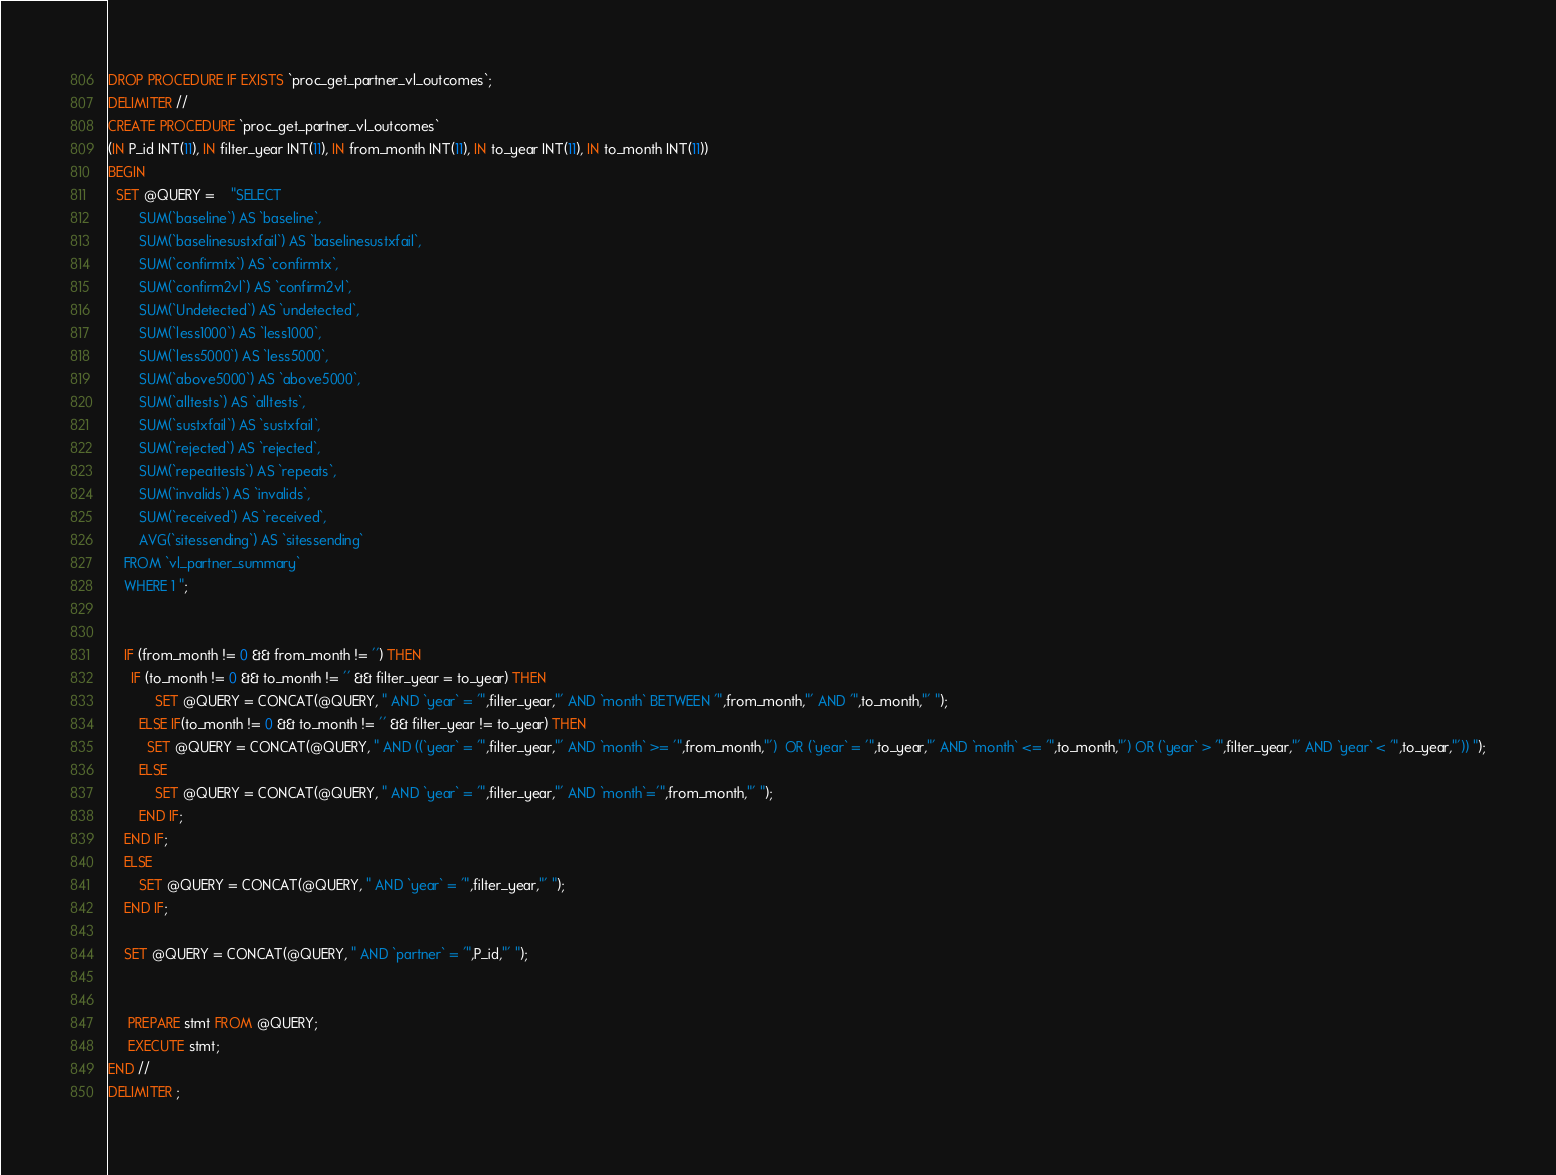<code> <loc_0><loc_0><loc_500><loc_500><_SQL_>DROP PROCEDURE IF EXISTS `proc_get_partner_vl_outcomes`;
DELIMITER //
CREATE PROCEDURE `proc_get_partner_vl_outcomes`
(IN P_id INT(11), IN filter_year INT(11), IN from_month INT(11), IN to_year INT(11), IN to_month INT(11))
BEGIN
  SET @QUERY =    "SELECT
        SUM(`baseline`) AS `baseline`, 
        SUM(`baselinesustxfail`) AS `baselinesustxfail`, 
        SUM(`confirmtx`) AS `confirmtx`,
        SUM(`confirm2vl`) AS `confirm2vl`,
        SUM(`Undetected`) AS `undetected`,
        SUM(`less1000`) AS `less1000`,
        SUM(`less5000`) AS `less5000`,
        SUM(`above5000`) AS `above5000`,
        SUM(`alltests`) AS `alltests`,
        SUM(`sustxfail`) AS `sustxfail`,
        SUM(`rejected`) AS `rejected`, 
        SUM(`repeattests`) AS `repeats`, 
        SUM(`invalids`) AS `invalids`,
        SUM(`received`) AS `received`,
        AVG(`sitessending`) AS `sitessending`
    FROM `vl_partner_summary`
    WHERE 1 ";


    IF (from_month != 0 && from_month != '') THEN
      IF (to_month != 0 && to_month != '' && filter_year = to_year) THEN
            SET @QUERY = CONCAT(@QUERY, " AND `year` = '",filter_year,"' AND `month` BETWEEN '",from_month,"' AND '",to_month,"' ");
        ELSE IF(to_month != 0 && to_month != '' && filter_year != to_year) THEN
          SET @QUERY = CONCAT(@QUERY, " AND ((`year` = '",filter_year,"' AND `month` >= '",from_month,"')  OR (`year` = '",to_year,"' AND `month` <= '",to_month,"') OR (`year` > '",filter_year,"' AND `year` < '",to_year,"')) ");
        ELSE
            SET @QUERY = CONCAT(@QUERY, " AND `year` = '",filter_year,"' AND `month`='",from_month,"' ");
        END IF;
    END IF;
    ELSE
        SET @QUERY = CONCAT(@QUERY, " AND `year` = '",filter_year,"' ");
    END IF;

    SET @QUERY = CONCAT(@QUERY, " AND `partner` = '",P_id,"' ");


     PREPARE stmt FROM @QUERY;
     EXECUTE stmt;
END //
DELIMITER ;
</code> 